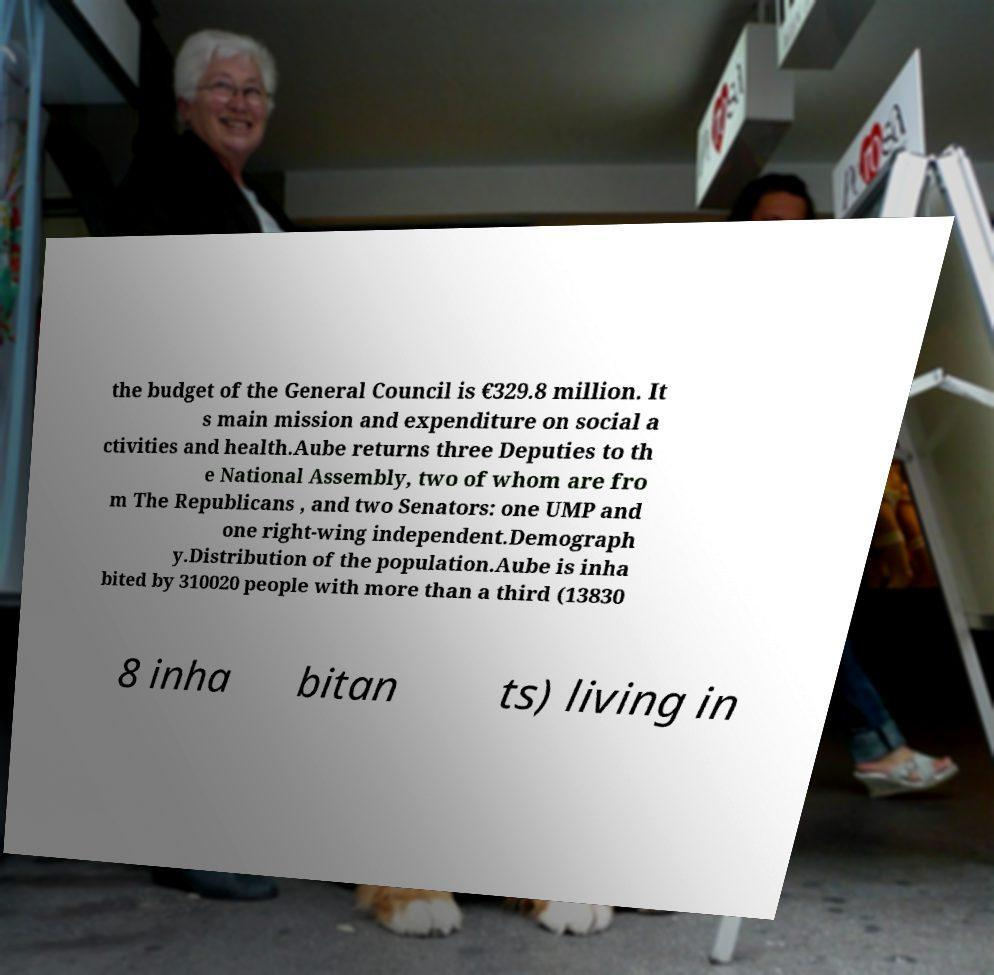Can you read and provide the text displayed in the image?This photo seems to have some interesting text. Can you extract and type it out for me? the budget of the General Council is €329.8 million. It s main mission and expenditure on social a ctivities and health.Aube returns three Deputies to th e National Assembly, two of whom are fro m The Republicans , and two Senators: one UMP and one right-wing independent.Demograph y.Distribution of the population.Aube is inha bited by 310020 people with more than a third (13830 8 inha bitan ts) living in 